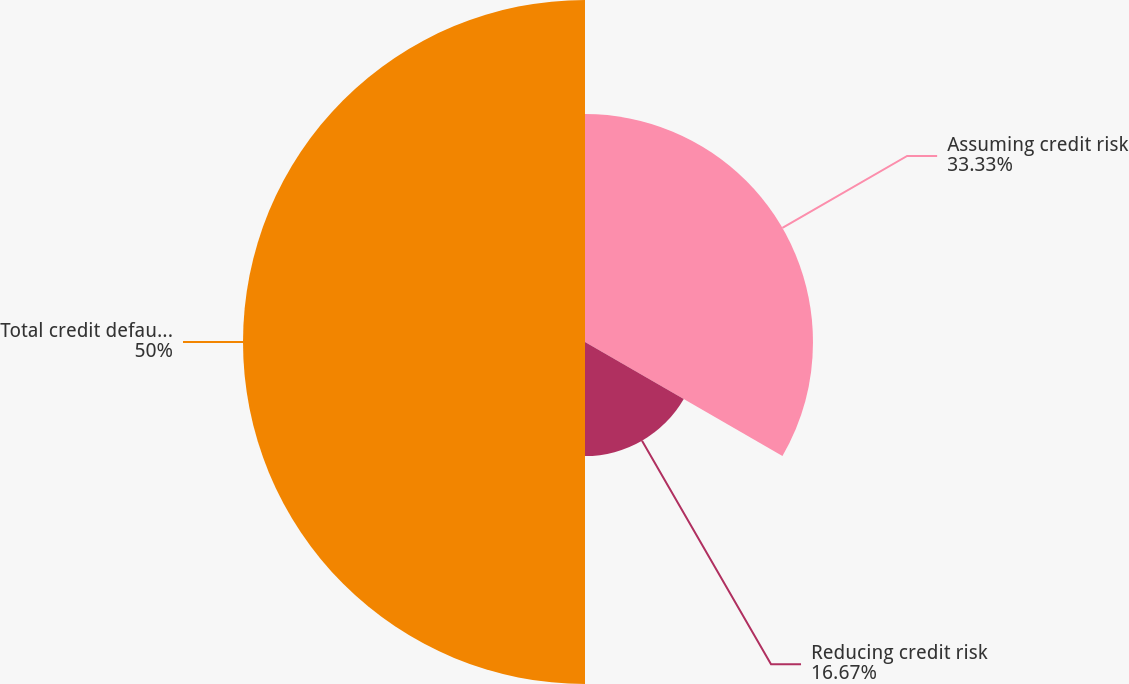Convert chart to OTSL. <chart><loc_0><loc_0><loc_500><loc_500><pie_chart><fcel>Assuming credit risk<fcel>Reducing credit risk<fcel>Total credit default swaps<nl><fcel>33.33%<fcel>16.67%<fcel>50.0%<nl></chart> 